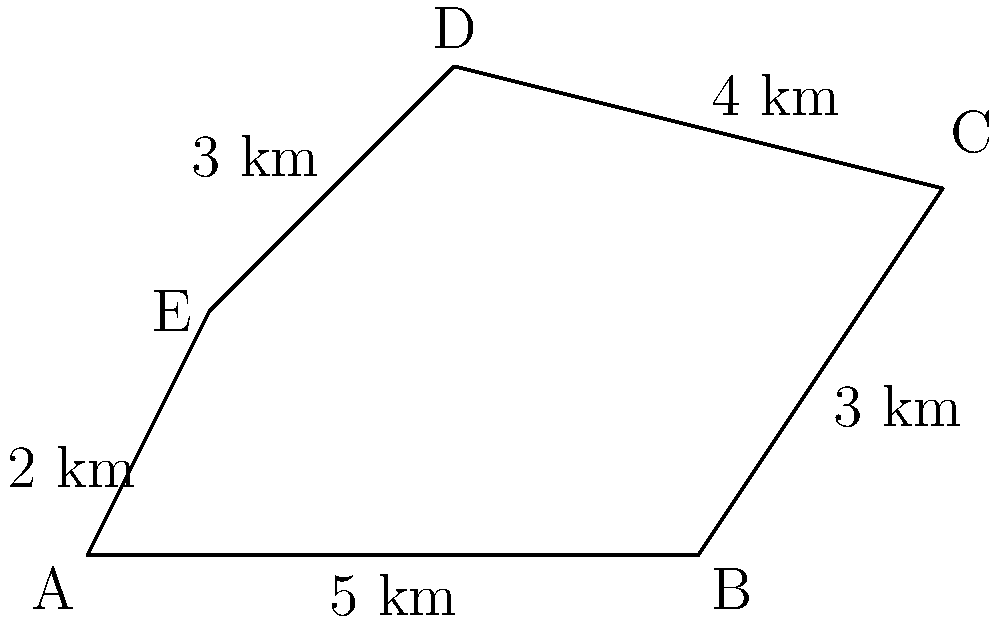A group of displaced families from the Guatemalan genocide has been relocated to a piece of land represented by the irregular pentagon ABCDE. If the government needs to calculate the area of this land to provide adequate resources, what is the total area in square kilometers? To calculate the area of this irregular pentagon, we can use the shoelace formula (also known as the surveyor's formula). The steps are as follows:

1) First, we need to identify the coordinates of each vertex. From the diagram:
   A(0,0), B(5,0), C(7,3), D(3,4), E(1,2)

2) The shoelace formula for a polygon with vertices $(x_1, y_1), (x_2, y_2), ..., (x_n, y_n)$ is:

   $$Area = \frac{1}{2}|(x_1y_2 + x_2y_3 + ... + x_ny_1) - (y_1x_2 + y_2x_3 + ... + y_nx_1)|$$

3) Applying this formula to our pentagon:

   $$Area = \frac{1}{2}|[(0 \cdot 0) + (5 \cdot 3) + (7 \cdot 4) + (3 \cdot 2) + (1 \cdot 0)] - [(0 \cdot 5) + (0 \cdot 7) + (3 \cdot 3) + (4 \cdot 1) + (2 \cdot 0)]|$$

4) Simplifying:

   $$Area = \frac{1}{2}|[0 + 15 + 28 + 6 + 0] - [0 + 0 + 9 + 4 + 0]|$$
   $$Area = \frac{1}{2}|49 - 13|$$
   $$Area = \frac{1}{2} \cdot 36$$
   $$Area = 18$$

Therefore, the total area of the land is 18 square kilometers.
Answer: 18 sq km 